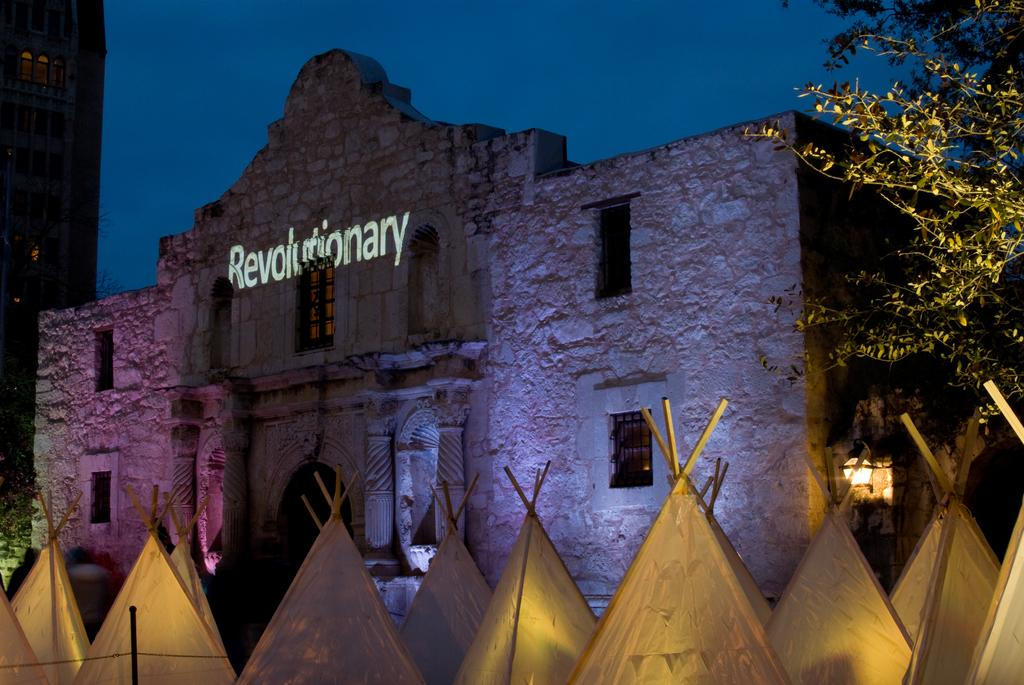<image>
Offer a succinct explanation of the picture presented. a twilight view of lit up tents in front of a old building reading Revolutionary 